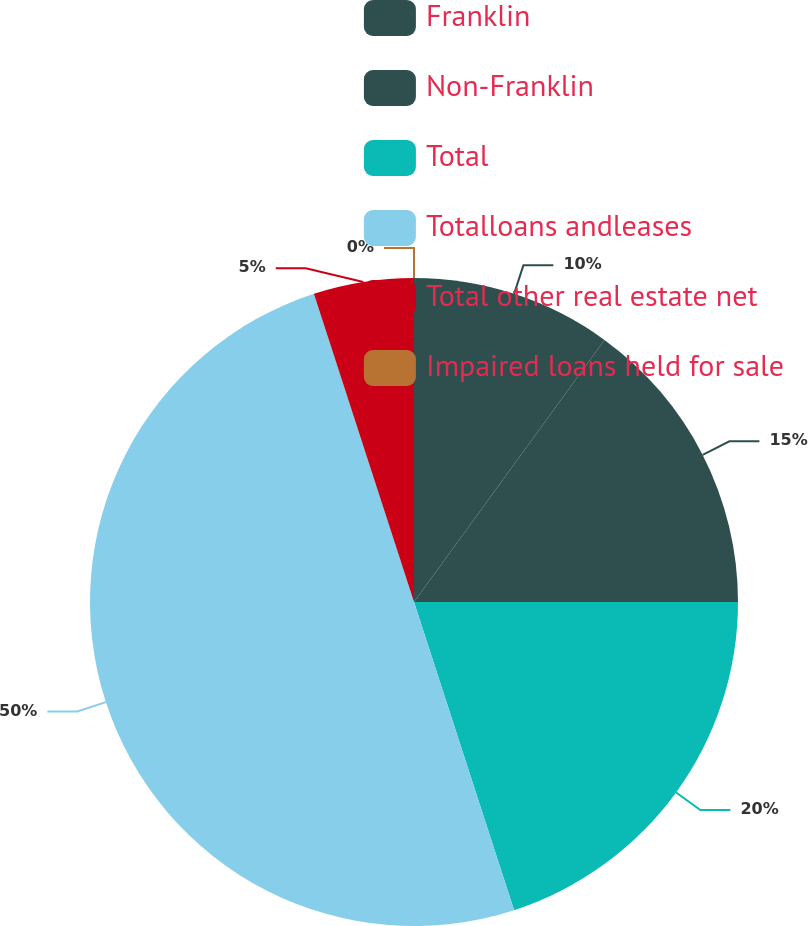Convert chart to OTSL. <chart><loc_0><loc_0><loc_500><loc_500><pie_chart><fcel>Franklin<fcel>Non-Franklin<fcel>Total<fcel>Totalloans andleases<fcel>Total other real estate net<fcel>Impaired loans held for sale<nl><fcel>10.0%<fcel>15.0%<fcel>20.0%<fcel>50.0%<fcel>5.0%<fcel>0.0%<nl></chart> 